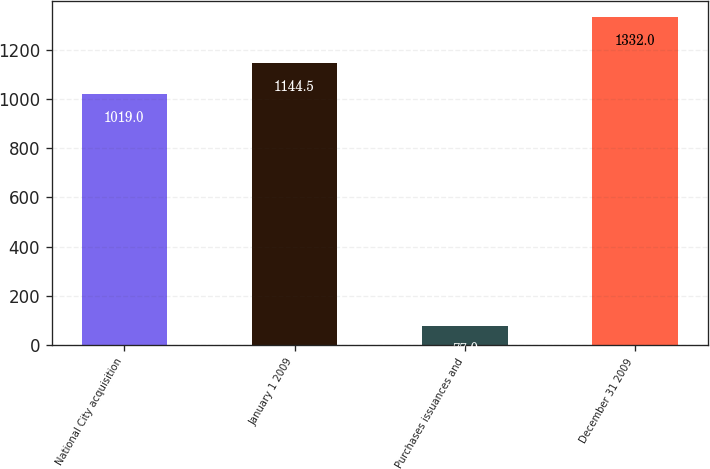<chart> <loc_0><loc_0><loc_500><loc_500><bar_chart><fcel>National City acquisition<fcel>January 1 2009<fcel>Purchases issuances and<fcel>December 31 2009<nl><fcel>1019<fcel>1144.5<fcel>77<fcel>1332<nl></chart> 